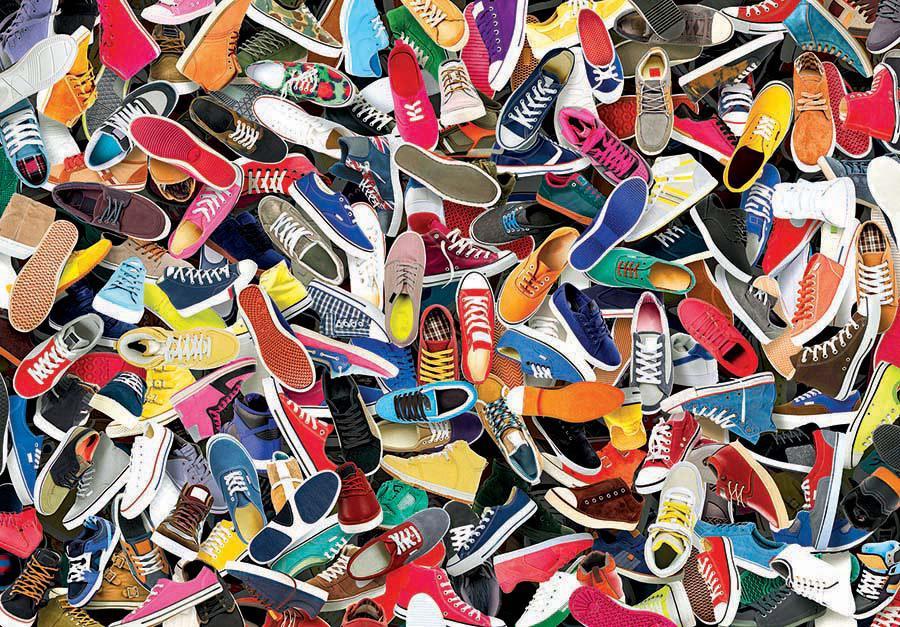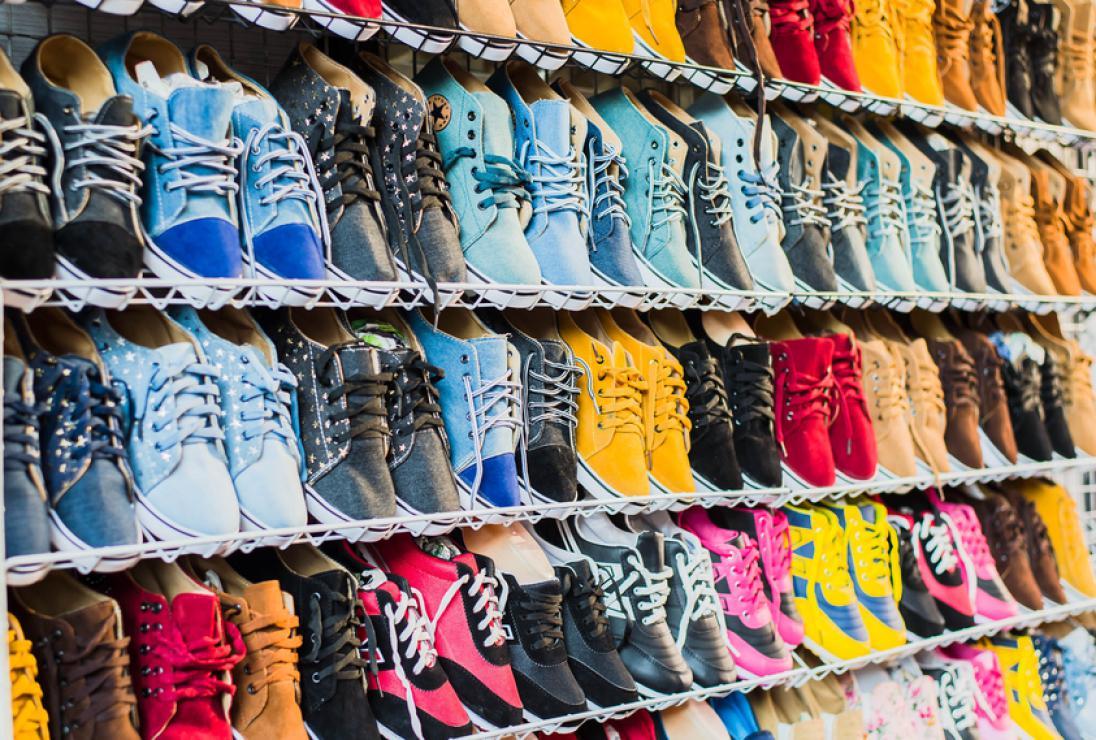The first image is the image on the left, the second image is the image on the right. For the images displayed, is the sentence "The shoes are arranged neatly on shelves in one of the iamges." factually correct? Answer yes or no. Yes. 